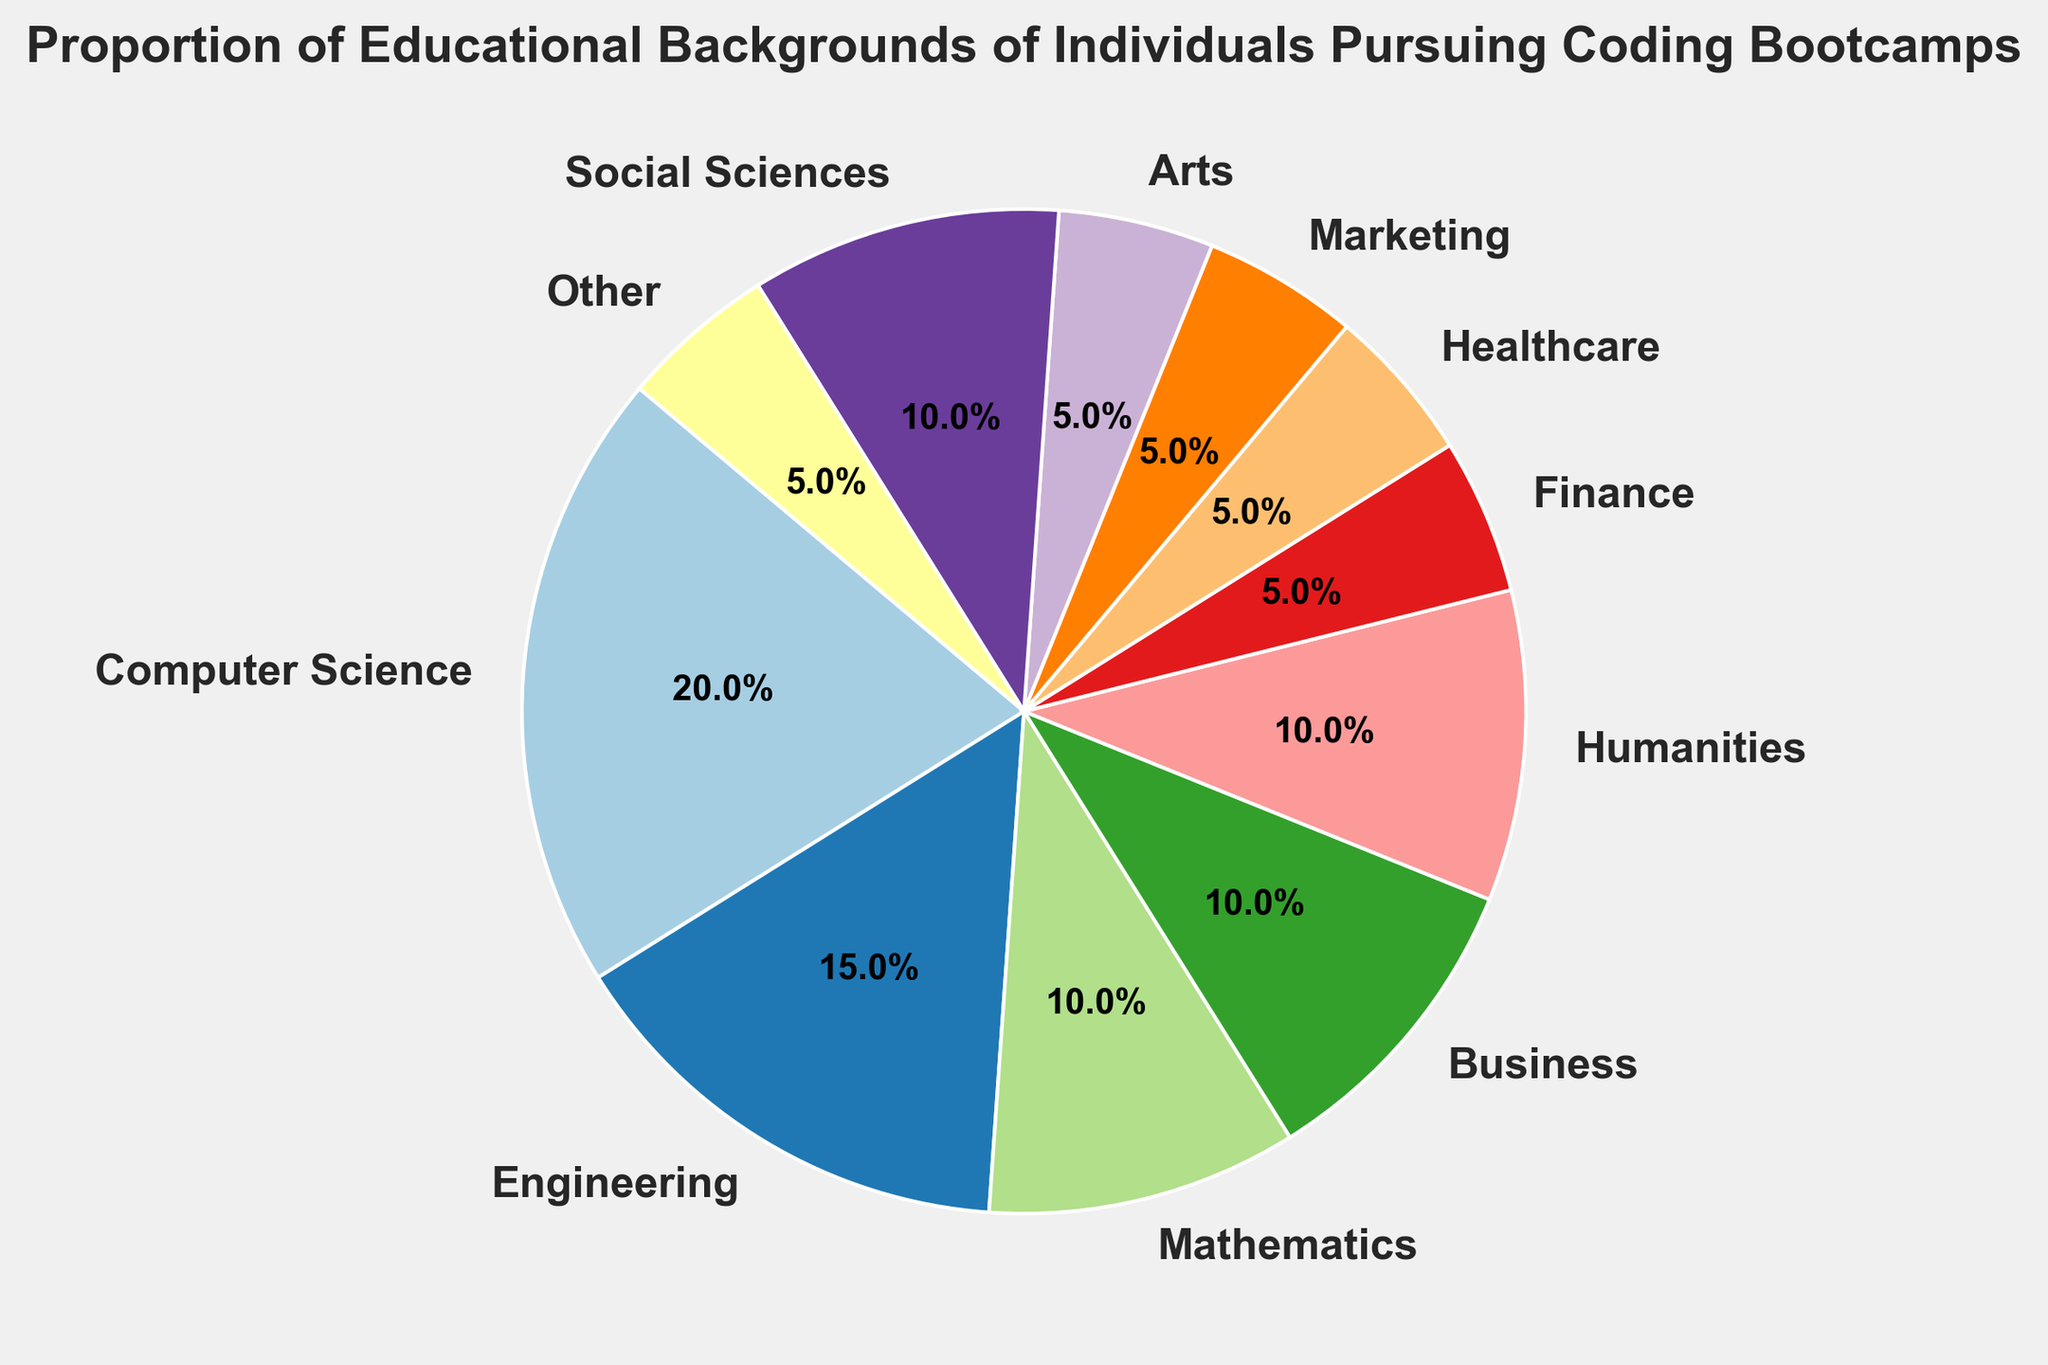How many different educational backgrounds are represented in the pie chart? The figure labels each slice with the name of an educational background. Count the unique labels to determine the number of different educational backgrounds.
Answer: 11 Which educational background has the largest proportion of individuals pursuing coding bootcamps? Look at the slice with the highest percentage label in the figure. The corresponding label denotes the educational background with the largest proportion.
Answer: Computer Science What's the combined proportion of individuals from Business, Humanities, and Social Sciences backgrounds? Identify the proportions for Business, Humanities, and Social Sciences in the chart and sum them up: 10% + 10% + 10%
Answer: 30% How does the proportion of individuals with a background in Healthcare compare to those in Marketing? Compare the percentage labels of the slices for Healthcare and Marketing. Both slices should have their proportions shown; if they are equal, state that.
Answer: Equal What is the proportion range (difference between the highest and lowest proportions) for the educational backgrounds in the pie chart? Identify the highest proportion (Computer Science at 20%) and the lowest proportion (multiple categories at 5%) and subtract the smallest proportion from the largest one: 20% - 5%
Answer: 15% Which two educational backgrounds have the smallest proportions of individuals pursuing coding bootcamps? Identify the slices with the smallest percentage labels in the figure. There are several categories at 5%, but two would be sufficient to answer the question.
Answer: Finance and Healthcare (or any other two among the 5% categories) What color is the segment representing individuals with a background in Engineering? Look at the segment labeled "Engineering" and describe the color of that segment. The color should be one of those used in the chart, often distinguished clearly.
Answer: Light Pink (or any color accurately observed in the rendered figure) By what percentage does the proportion of individuals from Mathematics backgrounds exceed those from Arts backgrounds? Identify the percentages for Mathematics (10%) and Arts (5%) and find the difference: 10% - 5%
Answer: 5% Which educational groups have a proportion of 10%? Look at the slices with the 10% label and list the corresponding educational backgrounds. There should be multiple categories with this proportion.
Answer: Mathematics, Business, Humanities, Social Sciences If you combine the proportions of individuals from Finance, Healthcare, Marketing, and Arts, would it exceed the proportion of individuals with a Computer Science background? Sum the proportions of Finance (5%), Healthcare (5%), Marketing (5%), and Arts (5%) and compare the total to the proportion of Computer Science (20%): 5% + 5% + 5% + 5% vs. 20%
Answer: No 